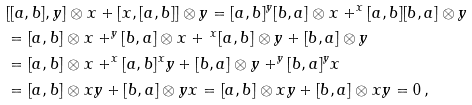Convert formula to latex. <formula><loc_0><loc_0><loc_500><loc_500>& [ [ a , b ] , y ] \otimes x + [ x , [ a , b ] ] \otimes y = [ a , b ] ^ { y } { [ b , a ] } \otimes x + ^ { x } { [ a , b ] } [ b , a ] \otimes y \\ & = [ a , b ] \otimes x + ^ { y } { [ b , a ] } \otimes x + \, ^ { x } [ a , b ] \otimes y + [ b , a ] \otimes y \\ & = [ a , b ] \otimes x + ^ { x } { [ a , b ] } ^ { x } y + [ b , a ] \otimes y + ^ { y } { [ b , a ] } ^ { y } x \\ & = [ a , b ] \otimes x y + [ b , a ] \otimes y x = [ a , b ] \otimes x y + [ b , a ] \otimes x y = 0 \, ,</formula> 